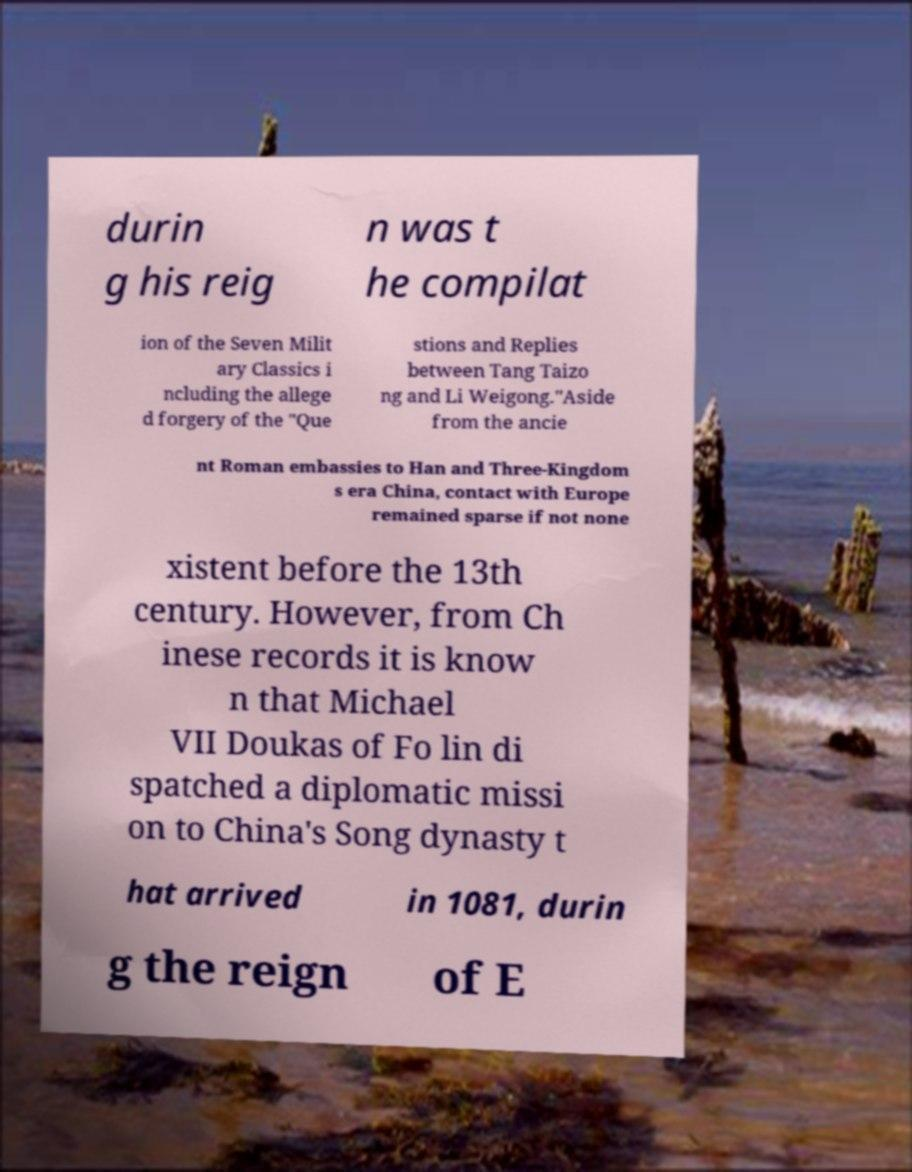Can you read and provide the text displayed in the image?This photo seems to have some interesting text. Can you extract and type it out for me? durin g his reig n was t he compilat ion of the Seven Milit ary Classics i ncluding the allege d forgery of the "Que stions and Replies between Tang Taizo ng and Li Weigong."Aside from the ancie nt Roman embassies to Han and Three-Kingdom s era China, contact with Europe remained sparse if not none xistent before the 13th century. However, from Ch inese records it is know n that Michael VII Doukas of Fo lin di spatched a diplomatic missi on to China's Song dynasty t hat arrived in 1081, durin g the reign of E 